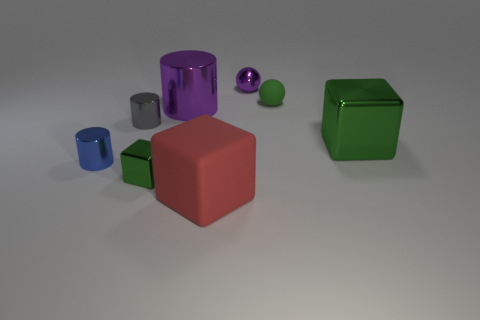Subtract all big red matte blocks. How many blocks are left? 2 Add 1 rubber cubes. How many objects exist? 9 Subtract all purple spheres. How many spheres are left? 1 Subtract 2 cylinders. How many cylinders are left? 1 Subtract all cylinders. How many objects are left? 5 Add 8 tiny matte things. How many tiny matte things are left? 9 Add 7 cylinders. How many cylinders exist? 10 Subtract 0 gray cubes. How many objects are left? 8 Subtract all blue cubes. Subtract all red cylinders. How many cubes are left? 3 Subtract all purple balls. How many gray cylinders are left? 1 